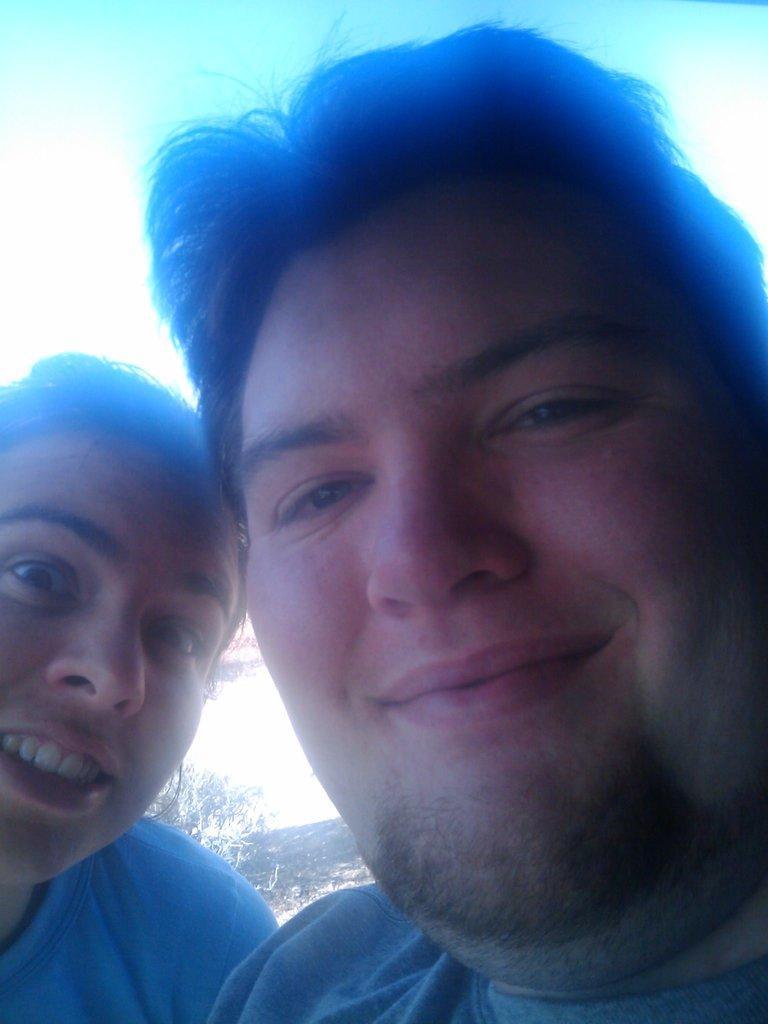Can you describe this image briefly? In this picture we can see two people and we can see sky in the background. 